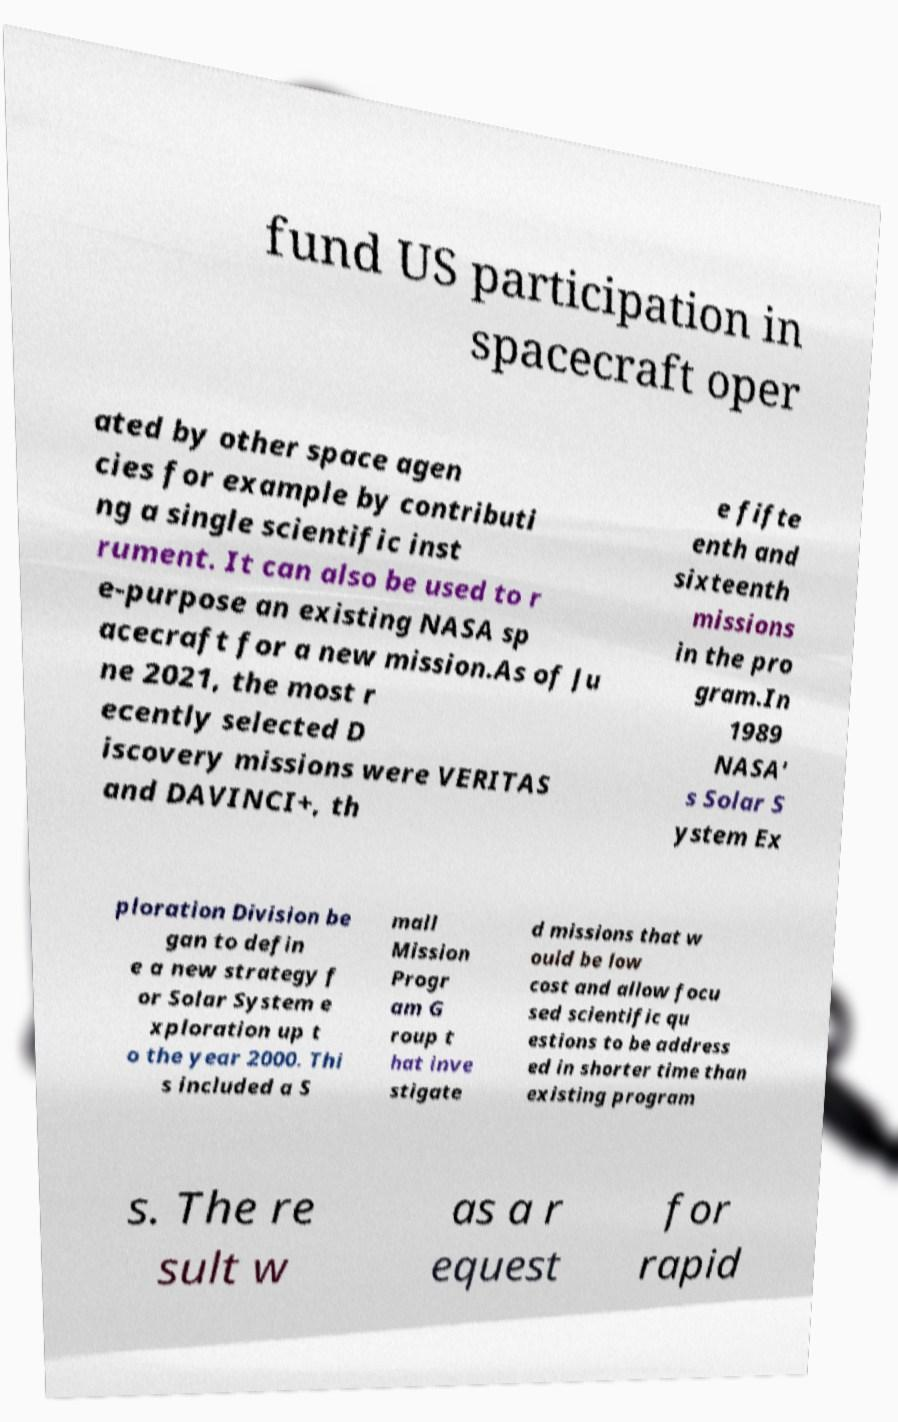Could you assist in decoding the text presented in this image and type it out clearly? fund US participation in spacecraft oper ated by other space agen cies for example by contributi ng a single scientific inst rument. It can also be used to r e-purpose an existing NASA sp acecraft for a new mission.As of Ju ne 2021, the most r ecently selected D iscovery missions were VERITAS and DAVINCI+, th e fifte enth and sixteenth missions in the pro gram.In 1989 NASA' s Solar S ystem Ex ploration Division be gan to defin e a new strategy f or Solar System e xploration up t o the year 2000. Thi s included a S mall Mission Progr am G roup t hat inve stigate d missions that w ould be low cost and allow focu sed scientific qu estions to be address ed in shorter time than existing program s. The re sult w as a r equest for rapid 